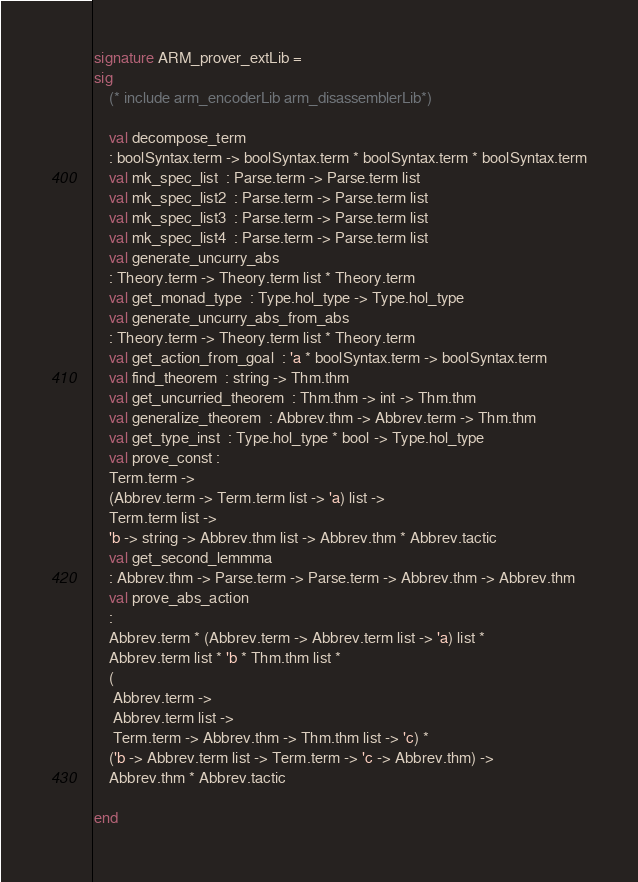Convert code to text. <code><loc_0><loc_0><loc_500><loc_500><_SML_>signature ARM_prover_extLib =
sig
    (* include arm_encoderLib arm_disassemblerLib*)

    val decompose_term
	: boolSyntax.term -> boolSyntax.term * boolSyntax.term * boolSyntax.term
    val mk_spec_list  : Parse.term -> Parse.term list
    val mk_spec_list2  : Parse.term -> Parse.term list
    val mk_spec_list3  : Parse.term -> Parse.term list
    val mk_spec_list4  : Parse.term -> Parse.term list
    val generate_uncurry_abs
	: Theory.term -> Theory.term list * Theory.term
    val get_monad_type  : Type.hol_type -> Type.hol_type
    val generate_uncurry_abs_from_abs
	: Theory.term -> Theory.term list * Theory.term
    val get_action_from_goal  : 'a * boolSyntax.term -> boolSyntax.term
    val find_theorem  : string -> Thm.thm
    val get_uncurried_theorem  : Thm.thm -> int -> Thm.thm
    val generalize_theorem  : Abbrev.thm -> Abbrev.term -> Thm.thm
    val get_type_inst  : Type.hol_type * bool -> Type.hol_type
    val prove_const :
	Term.term ->
	(Abbrev.term -> Term.term list -> 'a) list ->
	Term.term list ->
	'b -> string -> Abbrev.thm list -> Abbrev.thm * Abbrev.tactic
    val get_second_lemmma
	: Abbrev.thm -> Parse.term -> Parse.term -> Abbrev.thm -> Abbrev.thm
    val prove_abs_action
	:
	Abbrev.term * (Abbrev.term -> Abbrev.term list -> 'a) list *
	Abbrev.term list * 'b * Thm.thm list *
	(
	 Abbrev.term ->
	 Abbrev.term list ->
	 Term.term -> Abbrev.thm -> Thm.thm list -> 'c) *
	('b -> Abbrev.term list -> Term.term -> 'c -> Abbrev.thm) ->
	Abbrev.thm * Abbrev.tactic

end






</code> 